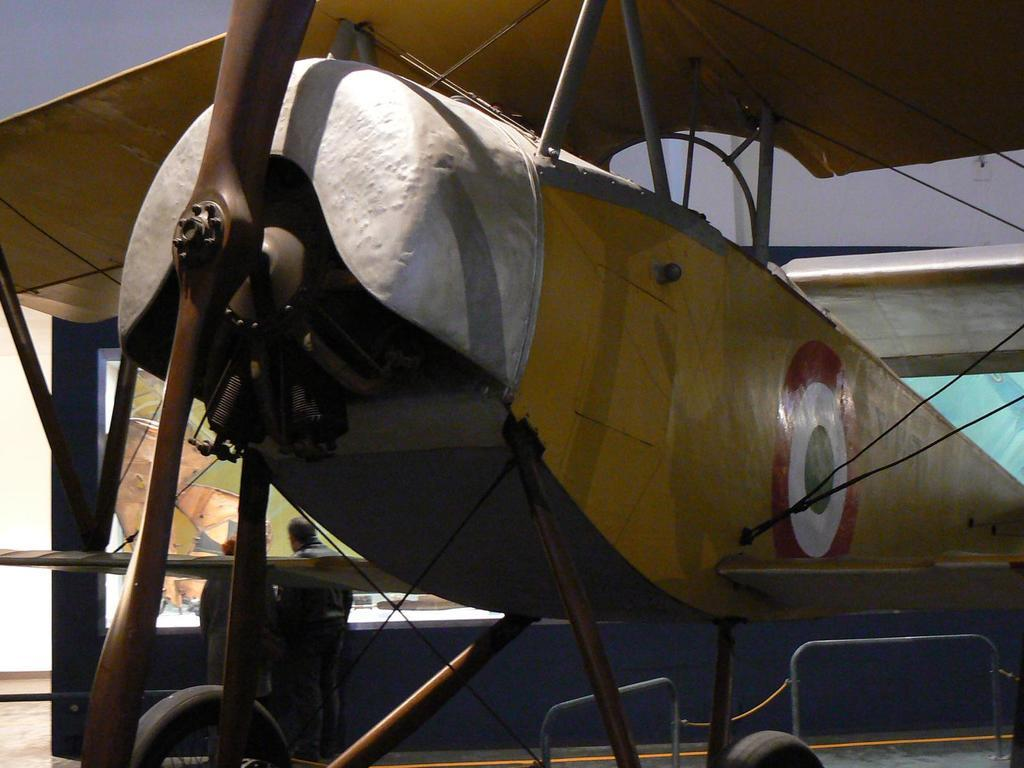What is the main subject in the center of the image? There is an object in the center of the image. What type of structure provides shelter in the image? There is a roof for shelter at the top of the image. How many people can be seen in the image? Two persons are visible in the image. What color is the mark left by the son on the object in the image? There is no mention of a mark or a son in the image, so we cannot determine the color of any mark. 